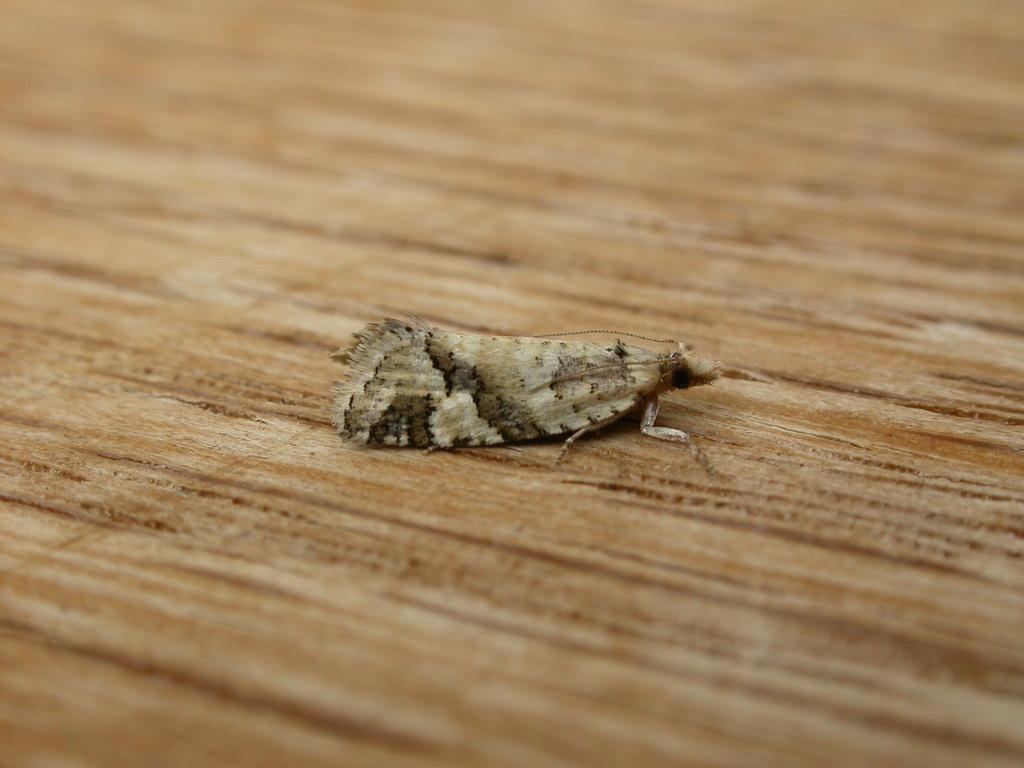Describe this image in one or two sentences. This picture shows a insect on the wood. 